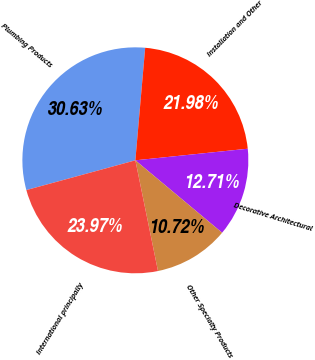Convert chart. <chart><loc_0><loc_0><loc_500><loc_500><pie_chart><fcel>Plumbing Products<fcel>Installation and Other<fcel>Decorative Architectural<fcel>Other Specialty Products<fcel>International principally<nl><fcel>30.63%<fcel>21.98%<fcel>12.71%<fcel>10.72%<fcel>23.97%<nl></chart> 